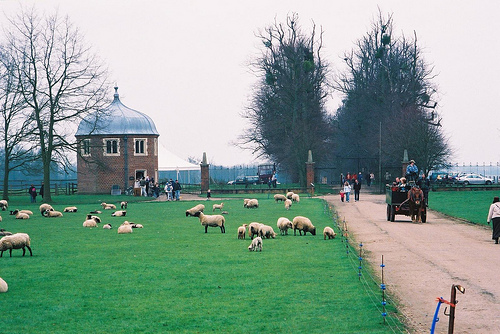Can you describe the setting depicted in the photo? The photo captures a pastoral scene, likely in a rural setting. There's a grassy field with several sheep grazing, and a traditional brick building with a domed roof on the left. A tree-lined road leads to a distant backdrop, possibly a park or a farm. The sky is overcast, suggesting it might be a cool day. 